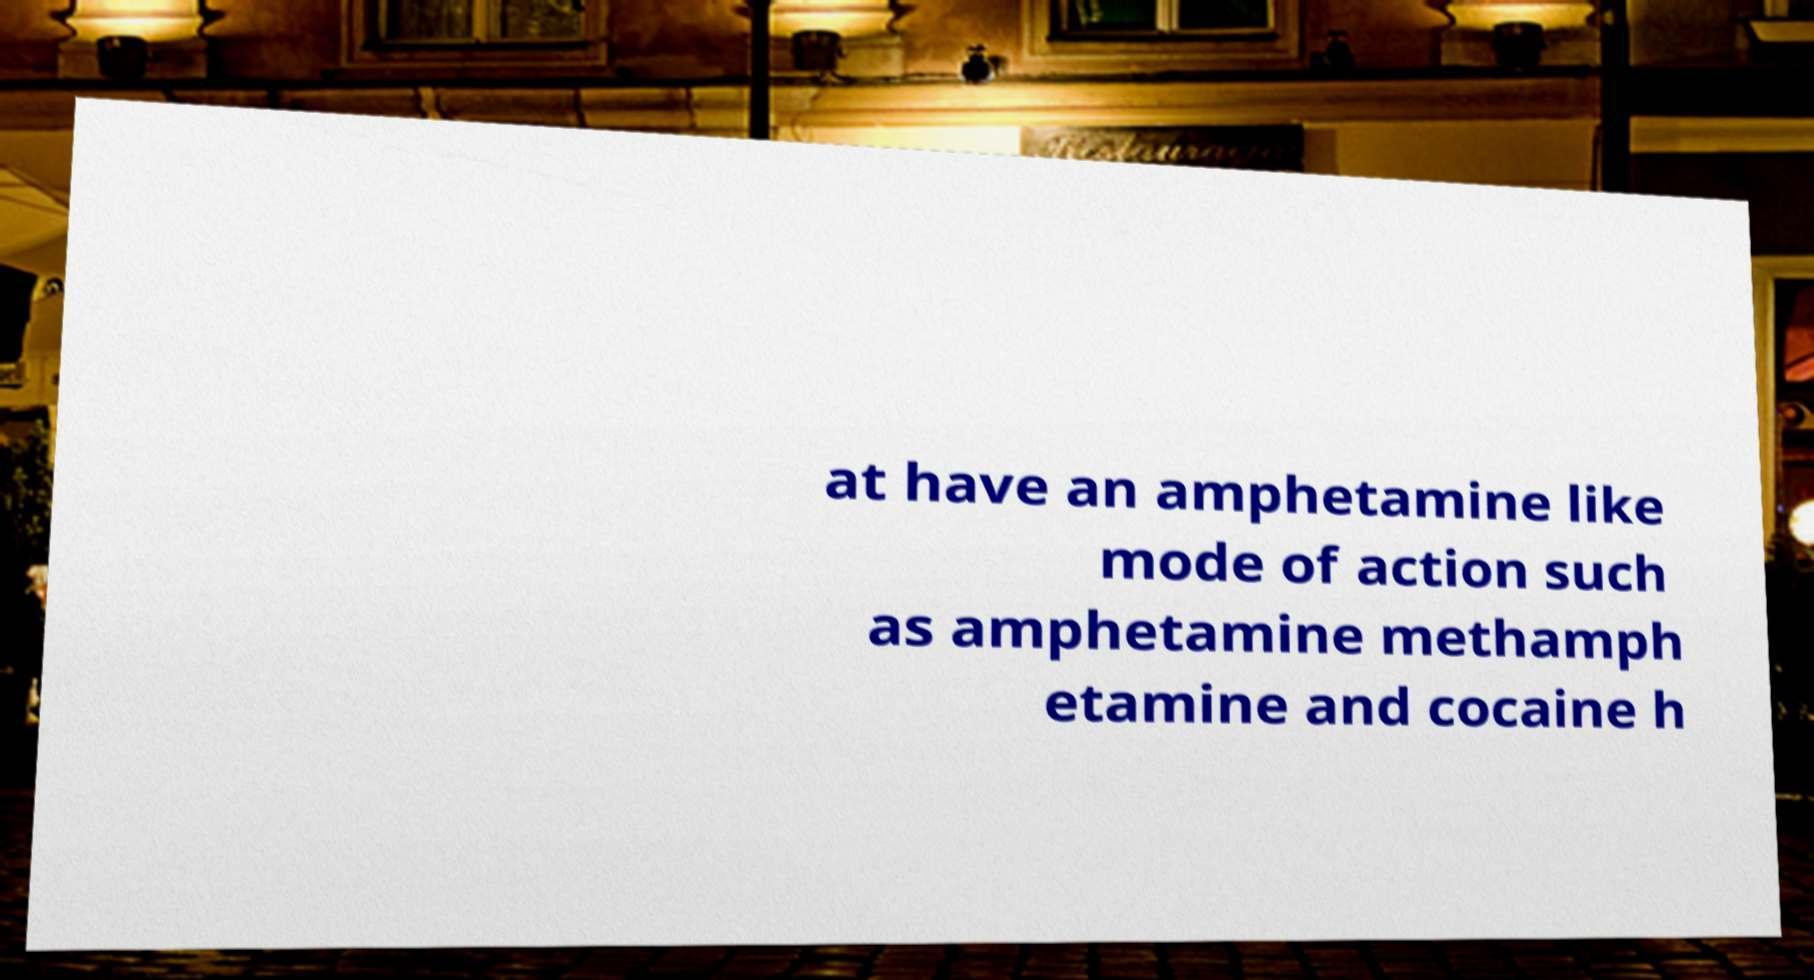There's text embedded in this image that I need extracted. Can you transcribe it verbatim? at have an amphetamine like mode of action such as amphetamine methamph etamine and cocaine h 